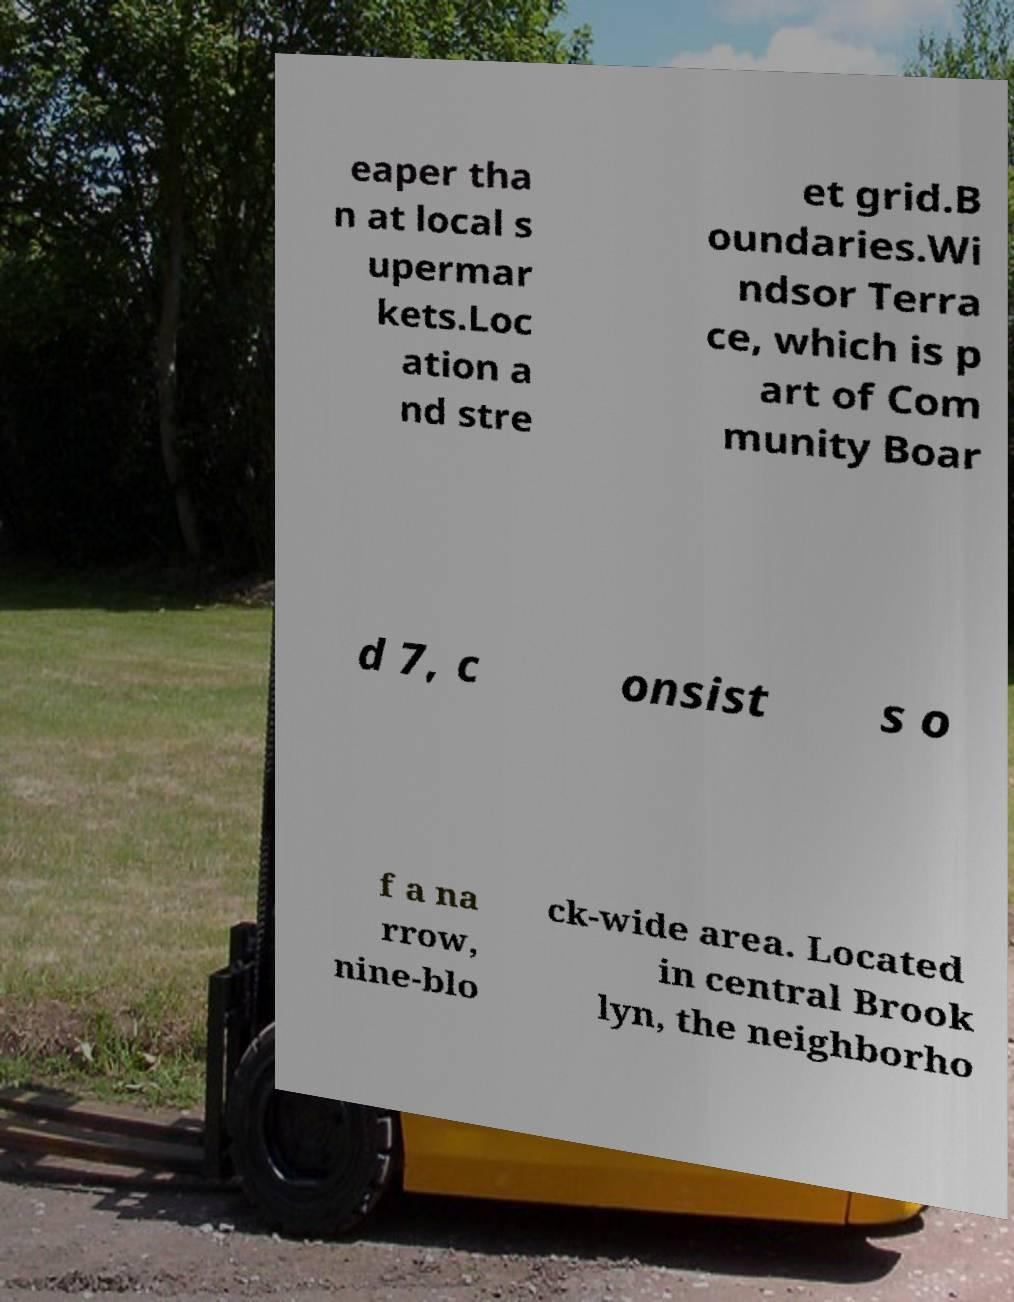Could you assist in decoding the text presented in this image and type it out clearly? eaper tha n at local s upermar kets.Loc ation a nd stre et grid.B oundaries.Wi ndsor Terra ce, which is p art of Com munity Boar d 7, c onsist s o f a na rrow, nine-blo ck-wide area. Located in central Brook lyn, the neighborho 